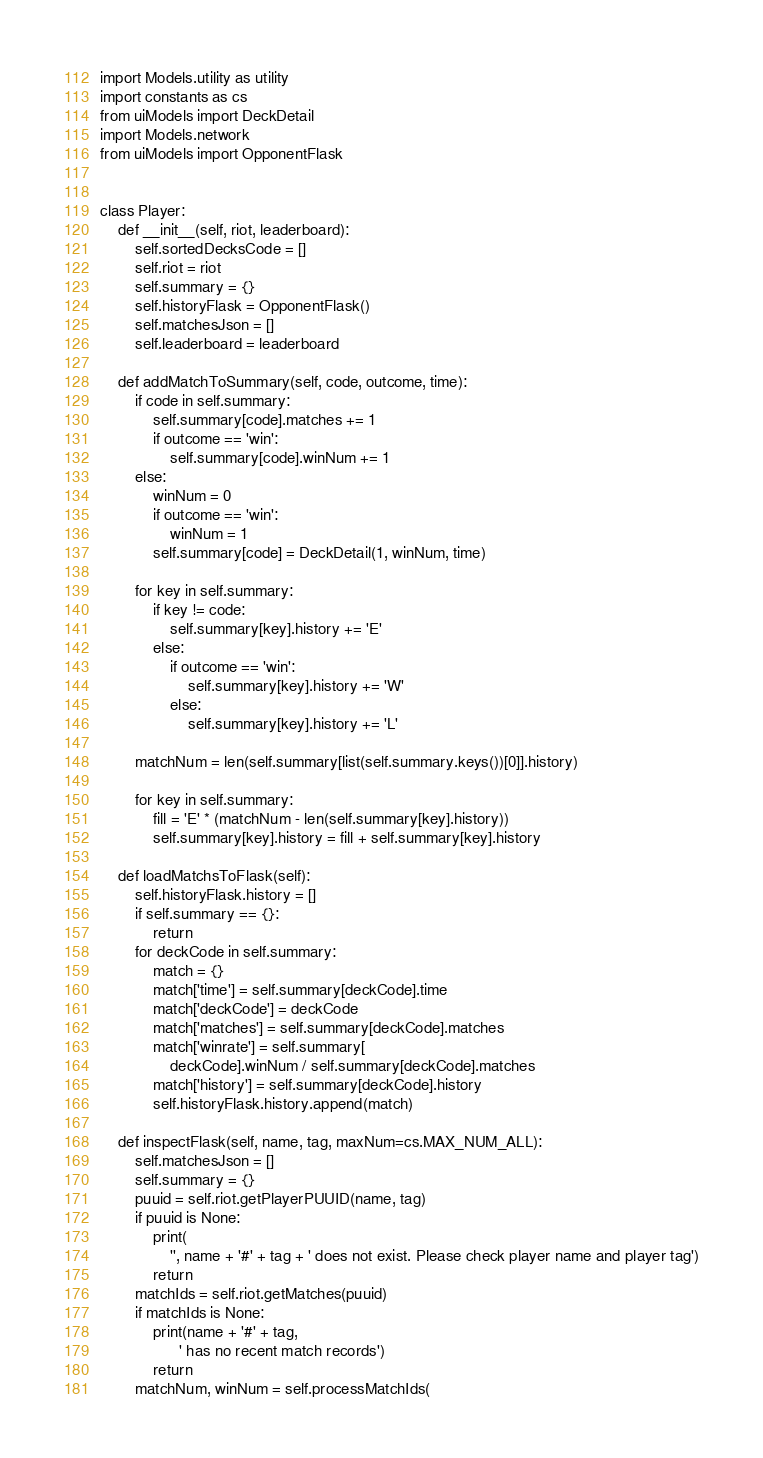Convert code to text. <code><loc_0><loc_0><loc_500><loc_500><_Python_>import Models.utility as utility
import constants as cs
from uiModels import DeckDetail
import Models.network
from uiModels import OpponentFlask


class Player:
    def __init__(self, riot, leaderboard):
        self.sortedDecksCode = []
        self.riot = riot
        self.summary = {}
        self.historyFlask = OpponentFlask()
        self.matchesJson = []
        self.leaderboard = leaderboard

    def addMatchToSummary(self, code, outcome, time):
        if code in self.summary:
            self.summary[code].matches += 1
            if outcome == 'win':
                self.summary[code].winNum += 1
        else:
            winNum = 0
            if outcome == 'win':
                winNum = 1
            self.summary[code] = DeckDetail(1, winNum, time)

        for key in self.summary:
            if key != code:
                self.summary[key].history += 'E'
            else:
                if outcome == 'win':
                    self.summary[key].history += 'W'
                else:
                    self.summary[key].history += 'L'

        matchNum = len(self.summary[list(self.summary.keys())[0]].history)

        for key in self.summary:
            fill = 'E' * (matchNum - len(self.summary[key].history))
            self.summary[key].history = fill + self.summary[key].history

    def loadMatchsToFlask(self):
        self.historyFlask.history = []
        if self.summary == {}:
            return
        for deckCode in self.summary:
            match = {}
            match['time'] = self.summary[deckCode].time
            match['deckCode'] = deckCode
            match['matches'] = self.summary[deckCode].matches
            match['winrate'] = self.summary[
                deckCode].winNum / self.summary[deckCode].matches
            match['history'] = self.summary[deckCode].history
            self.historyFlask.history.append(match)

    def inspectFlask(self, name, tag, maxNum=cs.MAX_NUM_ALL):
        self.matchesJson = []
        self.summary = {}
        puuid = self.riot.getPlayerPUUID(name, tag)
        if puuid is None:
            print(
                '', name + '#' + tag + ' does not exist. Please check player name and player tag')
            return
        matchIds = self.riot.getMatches(puuid)
        if matchIds is None:
            print(name + '#' + tag,
                  ' has no recent match records')
            return
        matchNum, winNum = self.processMatchIds(</code> 